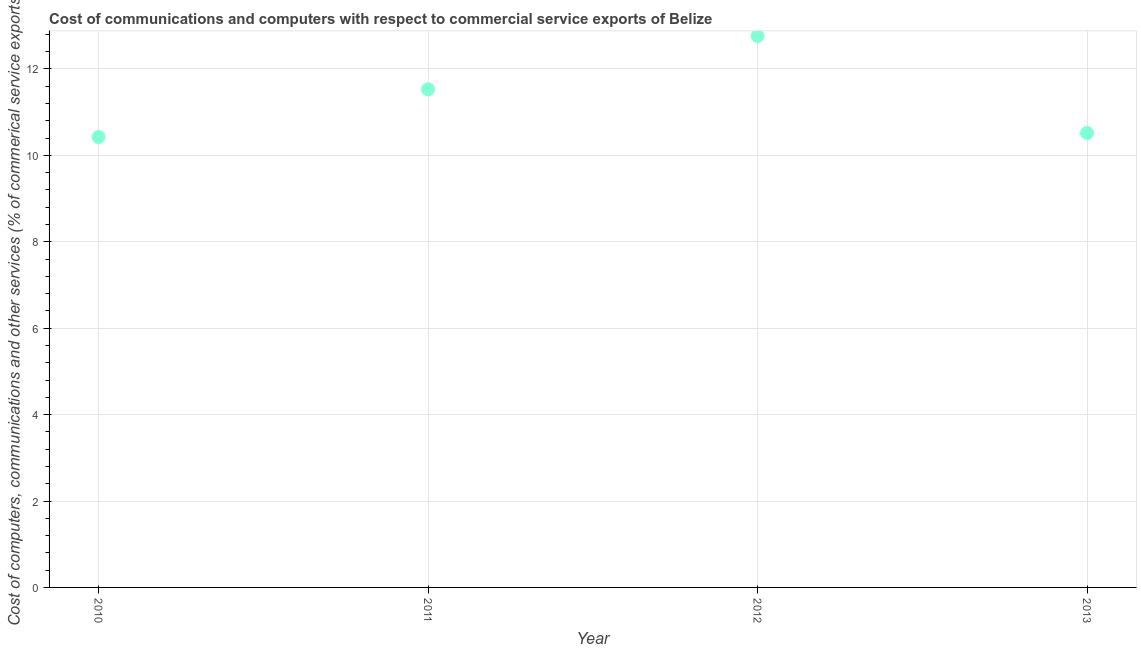What is the cost of communications in 2010?
Ensure brevity in your answer.  10.43. Across all years, what is the maximum  computer and other services?
Your answer should be very brief. 12.77. Across all years, what is the minimum cost of communications?
Make the answer very short. 10.43. In which year was the  computer and other services minimum?
Your response must be concise. 2010. What is the sum of the cost of communications?
Provide a short and direct response. 45.24. What is the difference between the  computer and other services in 2011 and 2012?
Your response must be concise. -1.24. What is the average  computer and other services per year?
Keep it short and to the point. 11.31. What is the median  computer and other services?
Make the answer very short. 11.02. In how many years, is the cost of communications greater than 4.8 %?
Make the answer very short. 4. What is the ratio of the cost of communications in 2010 to that in 2012?
Your answer should be compact. 0.82. Is the cost of communications in 2010 less than that in 2013?
Your response must be concise. Yes. Is the difference between the cost of communications in 2011 and 2013 greater than the difference between any two years?
Give a very brief answer. No. What is the difference between the highest and the second highest cost of communications?
Offer a terse response. 1.24. Is the sum of the  computer and other services in 2010 and 2012 greater than the maximum  computer and other services across all years?
Offer a terse response. Yes. What is the difference between the highest and the lowest  computer and other services?
Offer a very short reply. 2.34. In how many years, is the  computer and other services greater than the average  computer and other services taken over all years?
Give a very brief answer. 2. What is the difference between two consecutive major ticks on the Y-axis?
Offer a very short reply. 2. Are the values on the major ticks of Y-axis written in scientific E-notation?
Your answer should be very brief. No. Does the graph contain any zero values?
Ensure brevity in your answer.  No. Does the graph contain grids?
Offer a very short reply. Yes. What is the title of the graph?
Your answer should be compact. Cost of communications and computers with respect to commercial service exports of Belize. What is the label or title of the X-axis?
Your answer should be compact. Year. What is the label or title of the Y-axis?
Offer a terse response. Cost of computers, communications and other services (% of commerical service exports). What is the Cost of computers, communications and other services (% of commerical service exports) in 2010?
Offer a terse response. 10.43. What is the Cost of computers, communications and other services (% of commerical service exports) in 2011?
Offer a terse response. 11.53. What is the Cost of computers, communications and other services (% of commerical service exports) in 2012?
Provide a short and direct response. 12.77. What is the Cost of computers, communications and other services (% of commerical service exports) in 2013?
Keep it short and to the point. 10.52. What is the difference between the Cost of computers, communications and other services (% of commerical service exports) in 2010 and 2011?
Offer a very short reply. -1.1. What is the difference between the Cost of computers, communications and other services (% of commerical service exports) in 2010 and 2012?
Ensure brevity in your answer.  -2.34. What is the difference between the Cost of computers, communications and other services (% of commerical service exports) in 2010 and 2013?
Your answer should be compact. -0.09. What is the difference between the Cost of computers, communications and other services (% of commerical service exports) in 2011 and 2012?
Your answer should be compact. -1.24. What is the difference between the Cost of computers, communications and other services (% of commerical service exports) in 2011 and 2013?
Provide a short and direct response. 1.01. What is the difference between the Cost of computers, communications and other services (% of commerical service exports) in 2012 and 2013?
Keep it short and to the point. 2.25. What is the ratio of the Cost of computers, communications and other services (% of commerical service exports) in 2010 to that in 2011?
Give a very brief answer. 0.9. What is the ratio of the Cost of computers, communications and other services (% of commerical service exports) in 2010 to that in 2012?
Your answer should be compact. 0.82. What is the ratio of the Cost of computers, communications and other services (% of commerical service exports) in 2010 to that in 2013?
Make the answer very short. 0.99. What is the ratio of the Cost of computers, communications and other services (% of commerical service exports) in 2011 to that in 2012?
Your answer should be very brief. 0.9. What is the ratio of the Cost of computers, communications and other services (% of commerical service exports) in 2011 to that in 2013?
Offer a terse response. 1.1. What is the ratio of the Cost of computers, communications and other services (% of commerical service exports) in 2012 to that in 2013?
Provide a succinct answer. 1.21. 